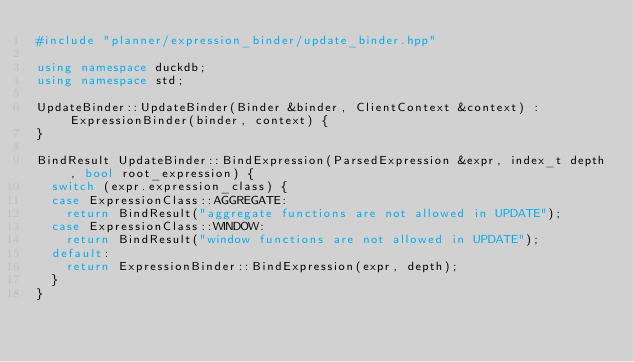Convert code to text. <code><loc_0><loc_0><loc_500><loc_500><_C++_>#include "planner/expression_binder/update_binder.hpp"

using namespace duckdb;
using namespace std;

UpdateBinder::UpdateBinder(Binder &binder, ClientContext &context) : ExpressionBinder(binder, context) {
}

BindResult UpdateBinder::BindExpression(ParsedExpression &expr, index_t depth, bool root_expression) {
	switch (expr.expression_class) {
	case ExpressionClass::AGGREGATE:
		return BindResult("aggregate functions are not allowed in UPDATE");
	case ExpressionClass::WINDOW:
		return BindResult("window functions are not allowed in UPDATE");
	default:
		return ExpressionBinder::BindExpression(expr, depth);
	}
}
</code> 